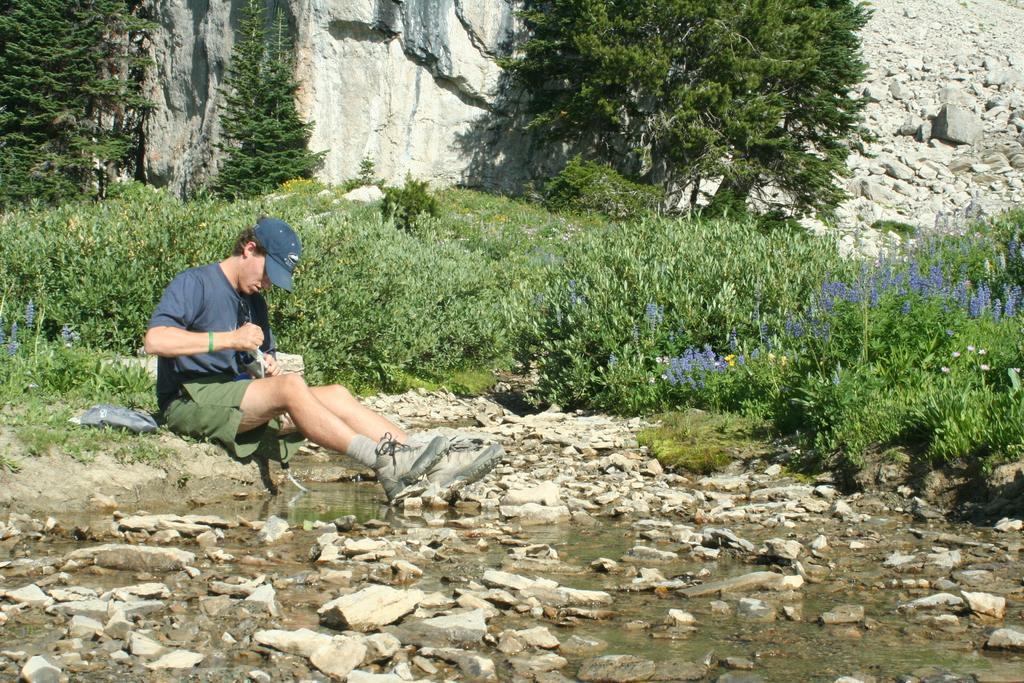Please provide a concise description of this image. This image is taken outdoors. At the bottom of the image there is a ground. There are many stones on the ground. In the background there is a rock. There are a few trees and plants with green leaves, stems and branches. There are many stones on the ground. In the middle of the image there is a ground with grass on it and a man is sitting on the ground and he is holding something in his hands. On the right side of the image there are a few plants with flowers. 